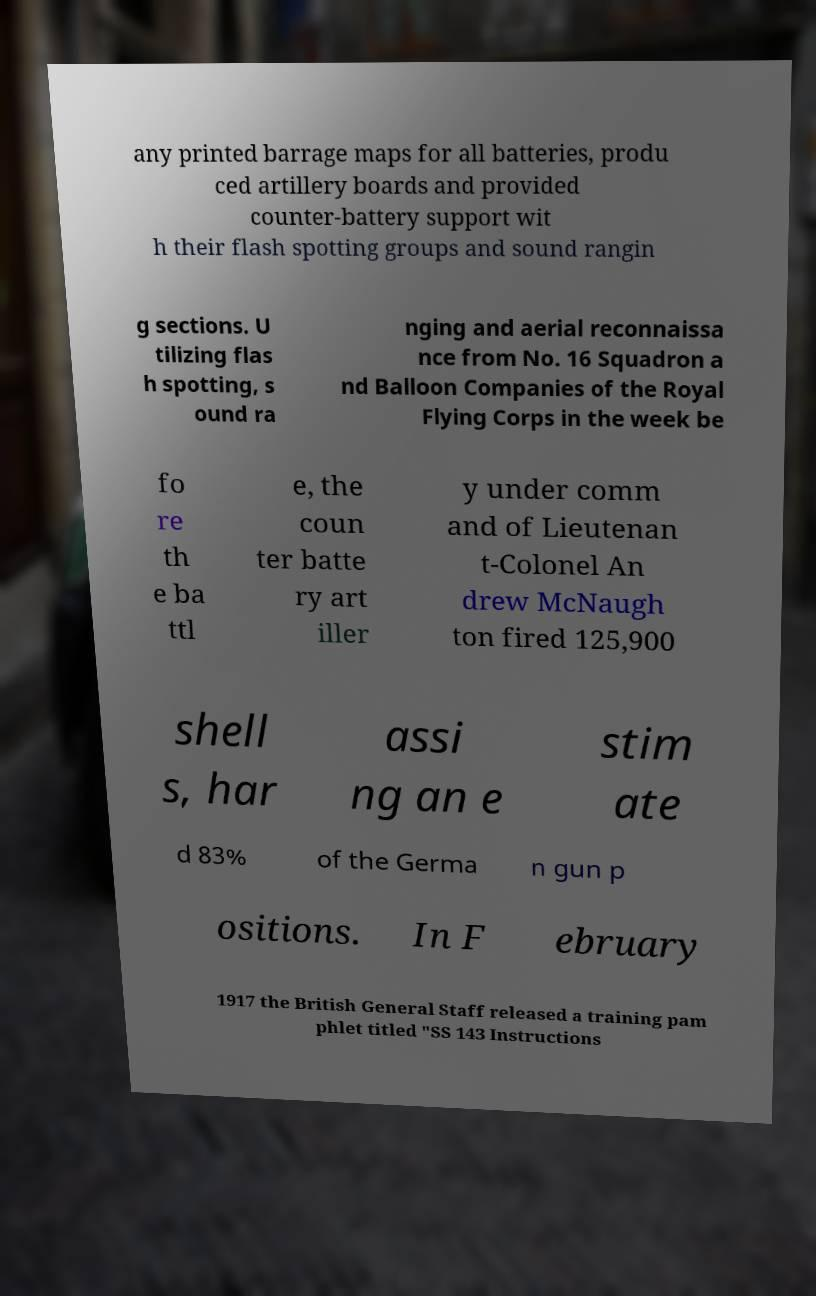Please read and relay the text visible in this image. What does it say? any printed barrage maps for all batteries, produ ced artillery boards and provided counter-battery support wit h their flash spotting groups and sound rangin g sections. U tilizing flas h spotting, s ound ra nging and aerial reconnaissa nce from No. 16 Squadron a nd Balloon Companies of the Royal Flying Corps in the week be fo re th e ba ttl e, the coun ter batte ry art iller y under comm and of Lieutenan t-Colonel An drew McNaugh ton fired 125,900 shell s, har assi ng an e stim ate d 83% of the Germa n gun p ositions. In F ebruary 1917 the British General Staff released a training pam phlet titled "SS 143 Instructions 